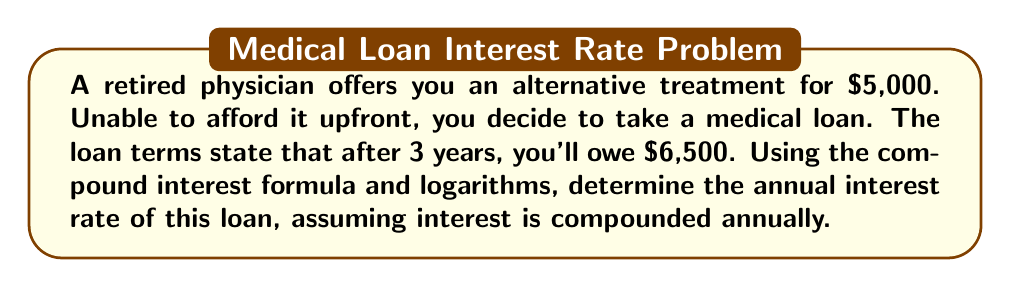Teach me how to tackle this problem. Let's approach this step-by-step using the compound interest formula and logarithms:

1) The compound interest formula is:
   $$A = P(1 + r)^t$$
   where A is the final amount, P is the principal (initial amount), r is the annual interest rate (in decimal form), and t is the time in years.

2) We know:
   P = $5,000 (initial loan amount)
   A = $6,500 (amount owed after 3 years)
   t = 3 years

3) Let's substitute these into the formula:
   $$6500 = 5000(1 + r)^3$$

4) Divide both sides by 5000:
   $$\frac{6500}{5000} = (1 + r)^3$$

5) Simplify:
   $$1.3 = (1 + r)^3$$

6) To isolate r, we need to take the cube root of both sides. We can do this using logarithms:
   $$\log(1.3) = \log((1 + r)^3)$$

7) Using the logarithm power rule:
   $$\log(1.3) = 3\log(1 + r)$$

8) Divide both sides by 3:
   $$\frac{\log(1.3)}{3} = \log(1 + r)$$

9) Now, we can use the inverse logarithm (exponential) to isolate r:
   $$10^{\frac{\log(1.3)}{3}} = 1 + r$$

10) Subtract 1 from both sides:
    $$10^{\frac{\log(1.3)}{3}} - 1 = r$$

11) Calculate:
    $$r \approx 0.0914 \text{ or } 9.14\%$$

Therefore, the annual interest rate is approximately 9.14%.
Answer: 9.14% 